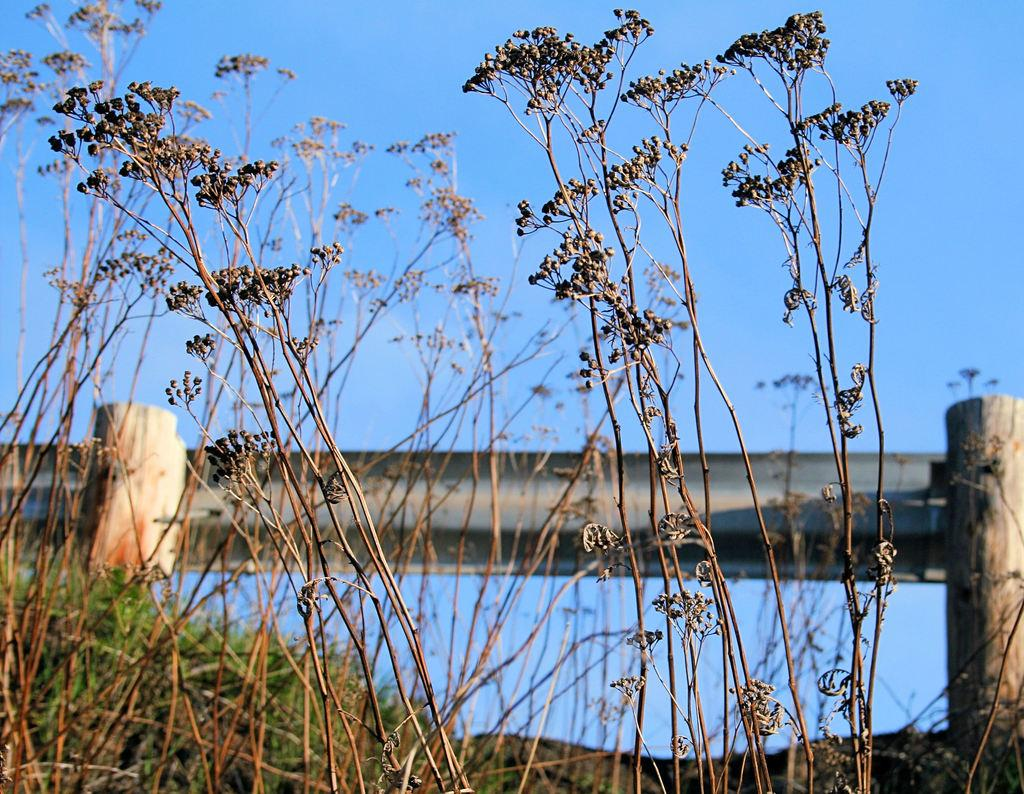What is located in the foreground of the picture? There are plants in the foreground of the picture. What type of vegetation is in the center of the picture? There is grass in the center of the picture. What architectural feature can be seen in the center of the picture? There is a railing in the center of the picture. How would you describe the weather in the picture? The sky is sunny, indicating good weather. What type of vegetable is growing on the canvas in the image? There is no canvas or vegetable present in the image. Can you see the seashore in the background of the image? The image does not depict a seashore; it features plants, grass, a railing, and a sunny sky. 